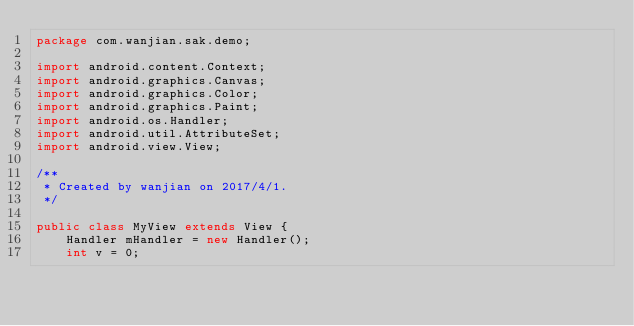<code> <loc_0><loc_0><loc_500><loc_500><_Java_>package com.wanjian.sak.demo;

import android.content.Context;
import android.graphics.Canvas;
import android.graphics.Color;
import android.graphics.Paint;
import android.os.Handler;
import android.util.AttributeSet;
import android.view.View;

/**
 * Created by wanjian on 2017/4/1.
 */

public class MyView extends View {
    Handler mHandler = new Handler();
    int v = 0;</code> 